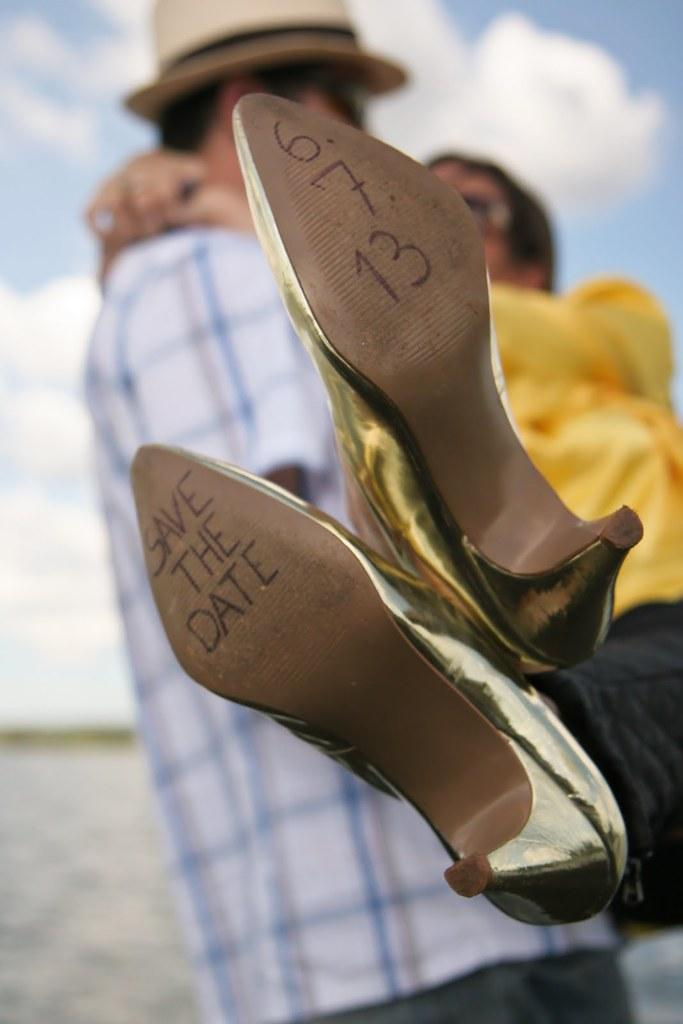What type of footwear is featured in the image? There are heels of a woman in the image. Are there any markings or details on the heels? Yes, there are dates written on the heels. Can you describe the relationship between the person and the woman be inferred from the image? The person is holding a woman behind the heels, which suggests a close relationship or interaction between them. What type of bubble can be seen in the image? There is no bubble present in the image. Where might the woman and the person be having lunch in the image? The image does not depict a lunchroom or any indication of a meal, so it cannot be determined where they might be having lunch. 